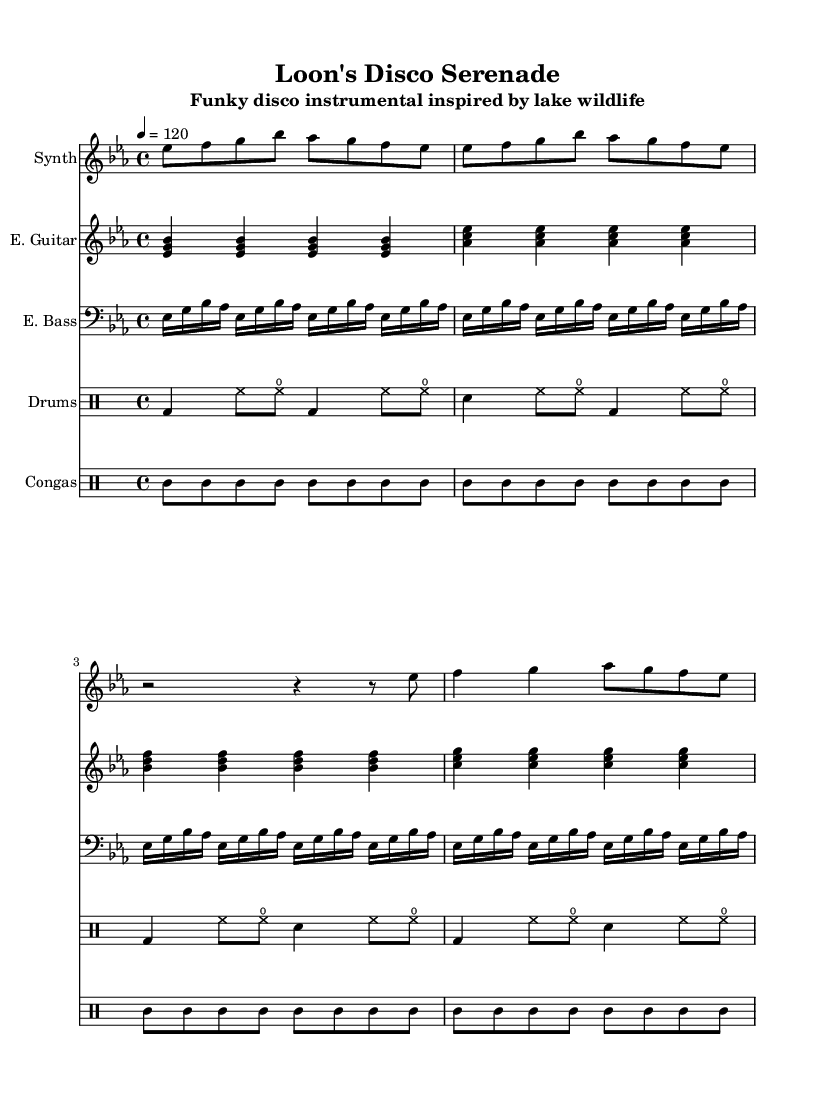What is the key signature of this music? The key signature is indicated at the beginning of the sheet music with the E flat major signature, which has three flats: B flat, E flat, and A flat.
Answer: E flat major What is the time signature of this music? The time signature is noted at the beginning of the score, shown as a fraction with 4 beats per measure and the quarter note receiving one beat. Thus, it is indicated as 4 over 4.
Answer: 4/4 What is the tempo marking of this piece? The tempo marking is specified as a quarter note equals 120 beats per minute, denoted in the score to guide the performance speed.
Answer: 120 Which instrument plays the melody? The melody is performed by the synthesizer, which is specified in the instrument name at the beginning of the melody staff.
Answer: Synth How many measures are in the electric bass part? By counting the individual groups of notes in the electric bass section, there are a total of 16 measures presented.
Answer: 16 What kind of rhythm is primarily used in the drumkit part? The rhythm in the drumkit part consists mainly of a combination of bass drum hits, hi-hat eighth notes, and snare drum hits in a steady upbeat tempo, common in disco music.
Answer: Disco groove Which unique musical feature reflects the aquatic theme in this piece? The use of syncopation and rhythmic patterns in the synthesizer and conga drums imitate the gentle ripples and lively movements of lake wildlife, making it reflective of water rhythms.
Answer: Water rhythms 